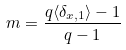Convert formula to latex. <formula><loc_0><loc_0><loc_500><loc_500>m = \frac { q \langle \delta _ { x , 1 } \rangle - 1 } { q - 1 }</formula> 